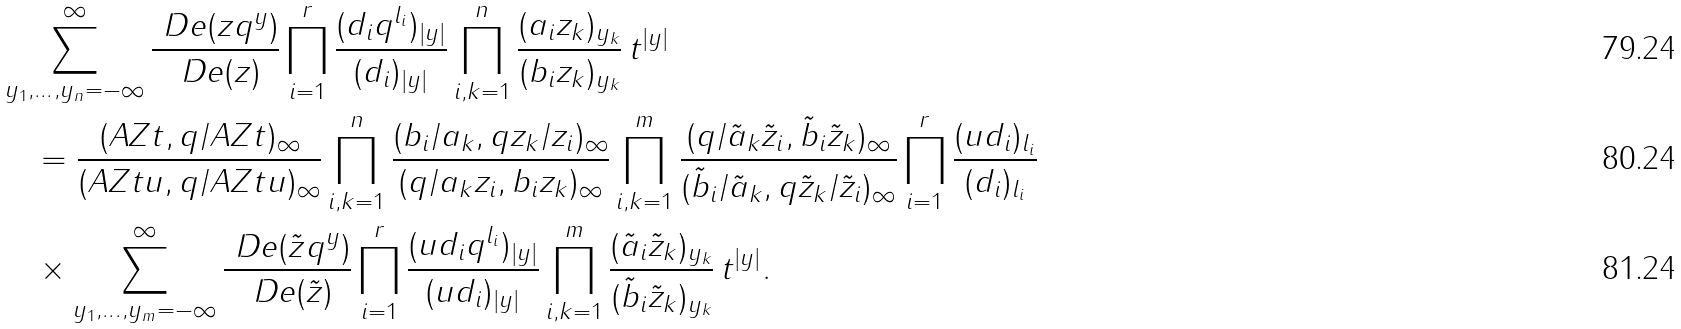<formula> <loc_0><loc_0><loc_500><loc_500>& \sum _ { y _ { 1 } , \dots , y _ { n } = - \infty } ^ { \infty } \frac { \ D e ( z q ^ { y } ) } { \ D e ( z ) } \prod _ { i = 1 } ^ { r } \frac { ( d _ { i } q ^ { l _ { i } } ) _ { | y | } } { ( d _ { i } ) _ { | y | } } \prod _ { i , k = 1 } ^ { n } \frac { ( a _ { i } z _ { k } ) _ { y _ { k } } } { ( b _ { i } z _ { k } ) _ { y _ { k } } } \, t ^ { | y | } \\ & \quad = \frac { ( A Z t , q / A Z t ) _ { \infty } } { ( A Z t u , q / A Z t u ) _ { \infty } } \prod _ { i , k = 1 } ^ { n } \frac { ( b _ { i } / a _ { k } , q z _ { k } / z _ { i } ) _ { \infty } } { ( q / a _ { k } z _ { i } , b _ { i } z _ { k } ) _ { \infty } } \prod _ { i , k = 1 } ^ { m } \frac { ( q / \tilde { a } _ { k } \tilde { z } _ { i } , \tilde { b } _ { i } \tilde { z } _ { k } ) _ { \infty } } { ( \tilde { b } _ { i } / \tilde { a } _ { k } , q \tilde { z } _ { k } / \tilde { z } _ { i } ) _ { \infty } } \prod _ { i = 1 } ^ { r } \frac { ( u d _ { i } ) _ { l _ { i } } } { ( d _ { i } ) _ { l _ { i } } } \\ & \quad \times \sum _ { y _ { 1 } , \dots , y _ { m } = - \infty } ^ { \infty } \frac { \ D e ( \tilde { z } q ^ { y } ) } { \ D e ( \tilde { z } ) } \prod _ { i = 1 } ^ { r } \frac { ( u d _ { i } q ^ { l _ { i } } ) _ { | y | } } { ( u d _ { i } ) _ { | y | } } \prod _ { i , k = 1 } ^ { m } \frac { ( \tilde { a } _ { i } \tilde { z } _ { k } ) _ { y _ { k } } } { ( \tilde { b } _ { i } \tilde { z } _ { k } ) _ { y _ { k } } } \, t ^ { | y | } .</formula> 